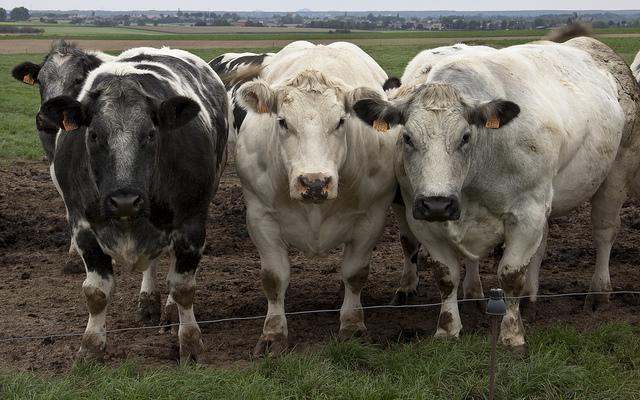Are the cows happy?
Give a very brief answer. No. Are the cows behind a fence?
Keep it brief. Yes. Are the cows facing the camera?
Be succinct. Yes. Are all the animals looking in the same direction?
Quick response, please. Yes. What type of animal is this?
Answer briefly. Cow. Are all cattle facing the camera?
Keep it brief. Yes. What color is the cow in the center?
Keep it brief. White. How many animals can be seen?
Concise answer only. 5. 